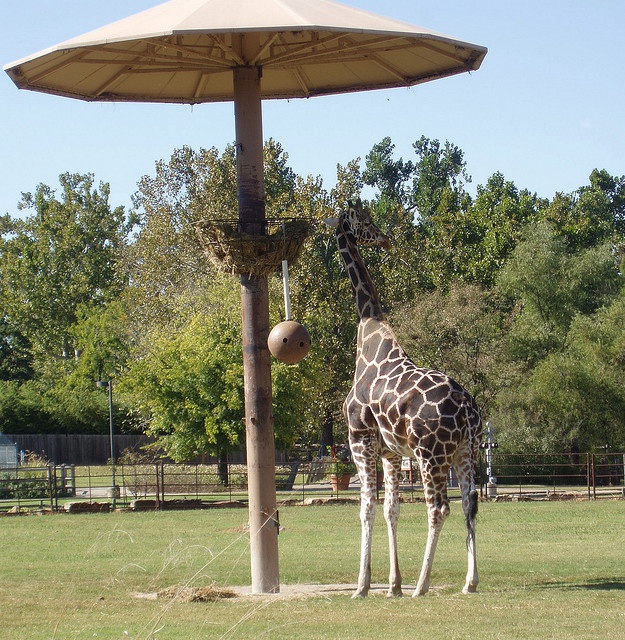Describe the objects in this image and their specific colors. I can see giraffe in lightblue, gray, black, ivory, and darkgray tones and umbrella in lightblue, gray, maroon, and black tones in this image. 